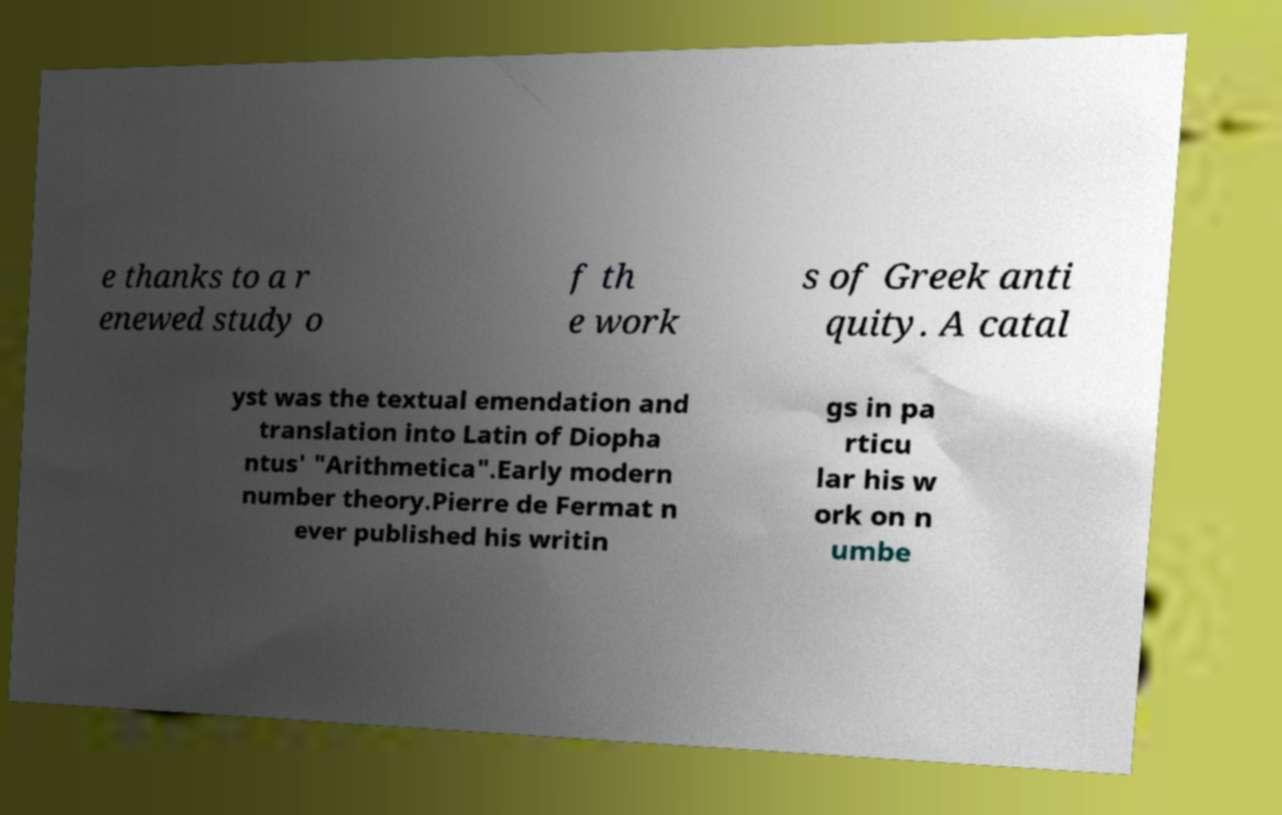Could you assist in decoding the text presented in this image and type it out clearly? e thanks to a r enewed study o f th e work s of Greek anti quity. A catal yst was the textual emendation and translation into Latin of Diopha ntus' "Arithmetica".Early modern number theory.Pierre de Fermat n ever published his writin gs in pa rticu lar his w ork on n umbe 